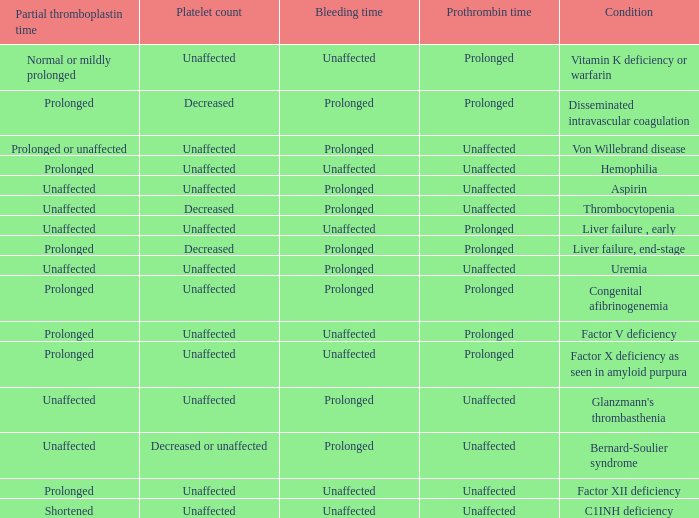Which Condition has an unaffected Prothrombin time and a Bleeding time, and a Partial thromboplastin time of prolonged? Hemophilia, Factor XII deficiency. 